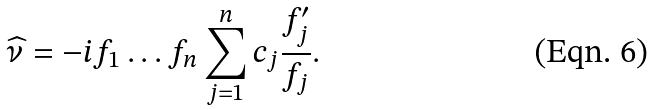<formula> <loc_0><loc_0><loc_500><loc_500>\widehat { \nu } = - i f _ { 1 } \dots f _ { n } \sum _ { j = 1 } ^ { n } c _ { j } \frac { f _ { j } ^ { \prime } } { f _ { j } } .</formula> 